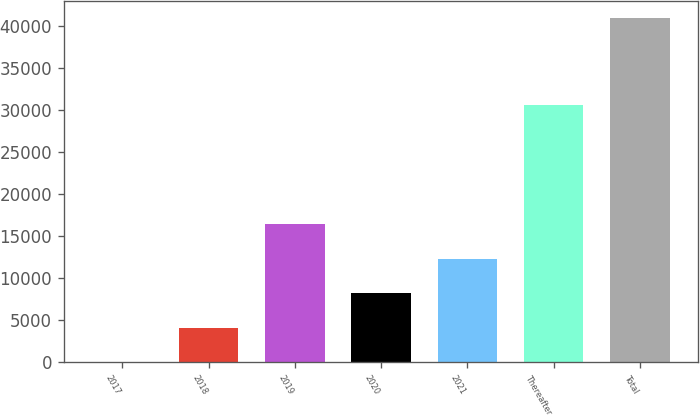Convert chart to OTSL. <chart><loc_0><loc_0><loc_500><loc_500><bar_chart><fcel>2017<fcel>2018<fcel>2019<fcel>2020<fcel>2021<fcel>Thereafter<fcel>Total<nl><fcel>2.29<fcel>4096.96<fcel>16381<fcel>8191.63<fcel>12286.3<fcel>30649<fcel>40949<nl></chart> 